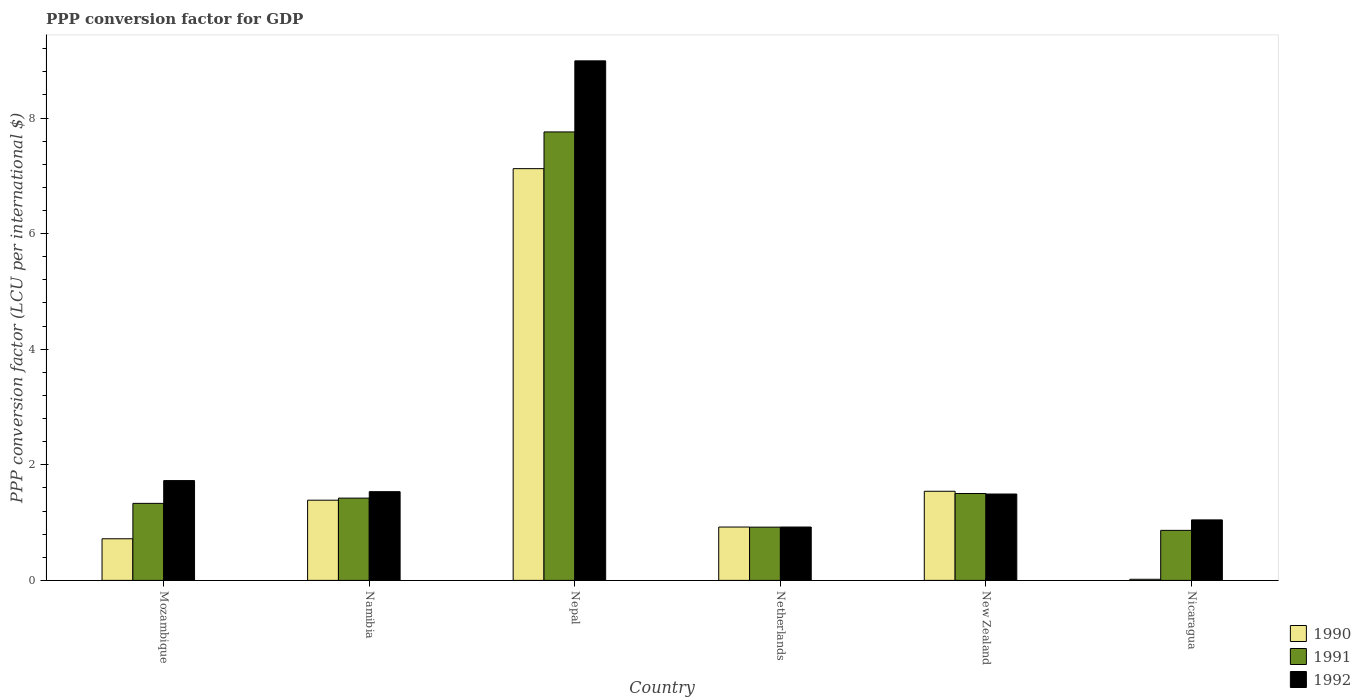How many different coloured bars are there?
Your response must be concise. 3. How many groups of bars are there?
Make the answer very short. 6. How many bars are there on the 5th tick from the left?
Provide a succinct answer. 3. How many bars are there on the 4th tick from the right?
Offer a terse response. 3. What is the label of the 6th group of bars from the left?
Ensure brevity in your answer.  Nicaragua. What is the PPP conversion factor for GDP in 1992 in Mozambique?
Ensure brevity in your answer.  1.73. Across all countries, what is the maximum PPP conversion factor for GDP in 1992?
Your response must be concise. 8.99. Across all countries, what is the minimum PPP conversion factor for GDP in 1990?
Your response must be concise. 0.02. In which country was the PPP conversion factor for GDP in 1991 maximum?
Keep it short and to the point. Nepal. In which country was the PPP conversion factor for GDP in 1992 minimum?
Keep it short and to the point. Netherlands. What is the total PPP conversion factor for GDP in 1992 in the graph?
Keep it short and to the point. 15.71. What is the difference between the PPP conversion factor for GDP in 1992 in Namibia and that in New Zealand?
Give a very brief answer. 0.04. What is the difference between the PPP conversion factor for GDP in 1992 in Nepal and the PPP conversion factor for GDP in 1991 in Namibia?
Your response must be concise. 7.57. What is the average PPP conversion factor for GDP in 1992 per country?
Your response must be concise. 2.62. What is the difference between the PPP conversion factor for GDP of/in 1990 and PPP conversion factor for GDP of/in 1992 in Nicaragua?
Your answer should be compact. -1.03. In how many countries, is the PPP conversion factor for GDP in 1990 greater than 7.2 LCU?
Your answer should be very brief. 0. What is the ratio of the PPP conversion factor for GDP in 1991 in Mozambique to that in New Zealand?
Give a very brief answer. 0.89. Is the difference between the PPP conversion factor for GDP in 1990 in Mozambique and Namibia greater than the difference between the PPP conversion factor for GDP in 1992 in Mozambique and Namibia?
Provide a short and direct response. No. What is the difference between the highest and the second highest PPP conversion factor for GDP in 1990?
Make the answer very short. 0.15. What is the difference between the highest and the lowest PPP conversion factor for GDP in 1990?
Your answer should be very brief. 7.1. What does the 1st bar from the right in Nicaragua represents?
Make the answer very short. 1992. How many bars are there?
Give a very brief answer. 18. Are all the bars in the graph horizontal?
Your response must be concise. No. How many countries are there in the graph?
Keep it short and to the point. 6. Does the graph contain any zero values?
Provide a short and direct response. No. How many legend labels are there?
Give a very brief answer. 3. What is the title of the graph?
Your response must be concise. PPP conversion factor for GDP. What is the label or title of the X-axis?
Make the answer very short. Country. What is the label or title of the Y-axis?
Give a very brief answer. PPP conversion factor (LCU per international $). What is the PPP conversion factor (LCU per international $) in 1990 in Mozambique?
Your answer should be very brief. 0.72. What is the PPP conversion factor (LCU per international $) in 1991 in Mozambique?
Give a very brief answer. 1.33. What is the PPP conversion factor (LCU per international $) of 1992 in Mozambique?
Your response must be concise. 1.73. What is the PPP conversion factor (LCU per international $) of 1990 in Namibia?
Your answer should be compact. 1.39. What is the PPP conversion factor (LCU per international $) of 1991 in Namibia?
Give a very brief answer. 1.42. What is the PPP conversion factor (LCU per international $) in 1992 in Namibia?
Provide a succinct answer. 1.53. What is the PPP conversion factor (LCU per international $) of 1990 in Nepal?
Offer a terse response. 7.12. What is the PPP conversion factor (LCU per international $) in 1991 in Nepal?
Offer a terse response. 7.76. What is the PPP conversion factor (LCU per international $) of 1992 in Nepal?
Make the answer very short. 8.99. What is the PPP conversion factor (LCU per international $) of 1990 in Netherlands?
Offer a terse response. 0.92. What is the PPP conversion factor (LCU per international $) in 1991 in Netherlands?
Keep it short and to the point. 0.92. What is the PPP conversion factor (LCU per international $) in 1992 in Netherlands?
Your answer should be compact. 0.92. What is the PPP conversion factor (LCU per international $) of 1990 in New Zealand?
Offer a very short reply. 1.54. What is the PPP conversion factor (LCU per international $) in 1991 in New Zealand?
Make the answer very short. 1.5. What is the PPP conversion factor (LCU per international $) in 1992 in New Zealand?
Your answer should be compact. 1.49. What is the PPP conversion factor (LCU per international $) in 1990 in Nicaragua?
Your answer should be compact. 0.02. What is the PPP conversion factor (LCU per international $) of 1991 in Nicaragua?
Offer a very short reply. 0.87. What is the PPP conversion factor (LCU per international $) in 1992 in Nicaragua?
Provide a short and direct response. 1.05. Across all countries, what is the maximum PPP conversion factor (LCU per international $) in 1990?
Your answer should be very brief. 7.12. Across all countries, what is the maximum PPP conversion factor (LCU per international $) of 1991?
Provide a succinct answer. 7.76. Across all countries, what is the maximum PPP conversion factor (LCU per international $) of 1992?
Ensure brevity in your answer.  8.99. Across all countries, what is the minimum PPP conversion factor (LCU per international $) of 1990?
Offer a terse response. 0.02. Across all countries, what is the minimum PPP conversion factor (LCU per international $) of 1991?
Ensure brevity in your answer.  0.87. Across all countries, what is the minimum PPP conversion factor (LCU per international $) of 1992?
Keep it short and to the point. 0.92. What is the total PPP conversion factor (LCU per international $) in 1990 in the graph?
Provide a succinct answer. 11.72. What is the total PPP conversion factor (LCU per international $) in 1991 in the graph?
Your answer should be compact. 13.81. What is the total PPP conversion factor (LCU per international $) of 1992 in the graph?
Make the answer very short. 15.71. What is the difference between the PPP conversion factor (LCU per international $) in 1990 in Mozambique and that in Namibia?
Make the answer very short. -0.67. What is the difference between the PPP conversion factor (LCU per international $) in 1991 in Mozambique and that in Namibia?
Offer a terse response. -0.09. What is the difference between the PPP conversion factor (LCU per international $) of 1992 in Mozambique and that in Namibia?
Your answer should be compact. 0.19. What is the difference between the PPP conversion factor (LCU per international $) in 1990 in Mozambique and that in Nepal?
Offer a very short reply. -6.4. What is the difference between the PPP conversion factor (LCU per international $) of 1991 in Mozambique and that in Nepal?
Your response must be concise. -6.43. What is the difference between the PPP conversion factor (LCU per international $) in 1992 in Mozambique and that in Nepal?
Provide a short and direct response. -7.26. What is the difference between the PPP conversion factor (LCU per international $) in 1990 in Mozambique and that in Netherlands?
Provide a short and direct response. -0.2. What is the difference between the PPP conversion factor (LCU per international $) in 1991 in Mozambique and that in Netherlands?
Ensure brevity in your answer.  0.41. What is the difference between the PPP conversion factor (LCU per international $) of 1992 in Mozambique and that in Netherlands?
Your response must be concise. 0.8. What is the difference between the PPP conversion factor (LCU per international $) of 1990 in Mozambique and that in New Zealand?
Your answer should be very brief. -0.82. What is the difference between the PPP conversion factor (LCU per international $) in 1991 in Mozambique and that in New Zealand?
Keep it short and to the point. -0.17. What is the difference between the PPP conversion factor (LCU per international $) in 1992 in Mozambique and that in New Zealand?
Make the answer very short. 0.23. What is the difference between the PPP conversion factor (LCU per international $) in 1990 in Mozambique and that in Nicaragua?
Ensure brevity in your answer.  0.7. What is the difference between the PPP conversion factor (LCU per international $) in 1991 in Mozambique and that in Nicaragua?
Your answer should be compact. 0.47. What is the difference between the PPP conversion factor (LCU per international $) of 1992 in Mozambique and that in Nicaragua?
Give a very brief answer. 0.68. What is the difference between the PPP conversion factor (LCU per international $) in 1990 in Namibia and that in Nepal?
Provide a succinct answer. -5.74. What is the difference between the PPP conversion factor (LCU per international $) of 1991 in Namibia and that in Nepal?
Your response must be concise. -6.34. What is the difference between the PPP conversion factor (LCU per international $) in 1992 in Namibia and that in Nepal?
Keep it short and to the point. -7.45. What is the difference between the PPP conversion factor (LCU per international $) in 1990 in Namibia and that in Netherlands?
Ensure brevity in your answer.  0.46. What is the difference between the PPP conversion factor (LCU per international $) of 1991 in Namibia and that in Netherlands?
Ensure brevity in your answer.  0.5. What is the difference between the PPP conversion factor (LCU per international $) of 1992 in Namibia and that in Netherlands?
Your answer should be compact. 0.61. What is the difference between the PPP conversion factor (LCU per international $) of 1990 in Namibia and that in New Zealand?
Make the answer very short. -0.15. What is the difference between the PPP conversion factor (LCU per international $) in 1991 in Namibia and that in New Zealand?
Offer a very short reply. -0.08. What is the difference between the PPP conversion factor (LCU per international $) of 1992 in Namibia and that in New Zealand?
Offer a very short reply. 0.04. What is the difference between the PPP conversion factor (LCU per international $) of 1990 in Namibia and that in Nicaragua?
Provide a short and direct response. 1.37. What is the difference between the PPP conversion factor (LCU per international $) of 1991 in Namibia and that in Nicaragua?
Provide a short and direct response. 0.56. What is the difference between the PPP conversion factor (LCU per international $) in 1992 in Namibia and that in Nicaragua?
Make the answer very short. 0.49. What is the difference between the PPP conversion factor (LCU per international $) in 1990 in Nepal and that in Netherlands?
Offer a very short reply. 6.2. What is the difference between the PPP conversion factor (LCU per international $) in 1991 in Nepal and that in Netherlands?
Your response must be concise. 6.84. What is the difference between the PPP conversion factor (LCU per international $) in 1992 in Nepal and that in Netherlands?
Make the answer very short. 8.07. What is the difference between the PPP conversion factor (LCU per international $) of 1990 in Nepal and that in New Zealand?
Your answer should be very brief. 5.58. What is the difference between the PPP conversion factor (LCU per international $) in 1991 in Nepal and that in New Zealand?
Provide a succinct answer. 6.26. What is the difference between the PPP conversion factor (LCU per international $) of 1992 in Nepal and that in New Zealand?
Give a very brief answer. 7.49. What is the difference between the PPP conversion factor (LCU per international $) in 1990 in Nepal and that in Nicaragua?
Your answer should be compact. 7.1. What is the difference between the PPP conversion factor (LCU per international $) in 1991 in Nepal and that in Nicaragua?
Give a very brief answer. 6.89. What is the difference between the PPP conversion factor (LCU per international $) of 1992 in Nepal and that in Nicaragua?
Make the answer very short. 7.94. What is the difference between the PPP conversion factor (LCU per international $) in 1990 in Netherlands and that in New Zealand?
Your answer should be very brief. -0.62. What is the difference between the PPP conversion factor (LCU per international $) of 1991 in Netherlands and that in New Zealand?
Offer a very short reply. -0.58. What is the difference between the PPP conversion factor (LCU per international $) in 1992 in Netherlands and that in New Zealand?
Your response must be concise. -0.57. What is the difference between the PPP conversion factor (LCU per international $) of 1990 in Netherlands and that in Nicaragua?
Offer a very short reply. 0.9. What is the difference between the PPP conversion factor (LCU per international $) of 1991 in Netherlands and that in Nicaragua?
Make the answer very short. 0.06. What is the difference between the PPP conversion factor (LCU per international $) of 1992 in Netherlands and that in Nicaragua?
Keep it short and to the point. -0.12. What is the difference between the PPP conversion factor (LCU per international $) of 1990 in New Zealand and that in Nicaragua?
Your response must be concise. 1.52. What is the difference between the PPP conversion factor (LCU per international $) of 1991 in New Zealand and that in Nicaragua?
Provide a succinct answer. 0.64. What is the difference between the PPP conversion factor (LCU per international $) of 1992 in New Zealand and that in Nicaragua?
Your answer should be very brief. 0.45. What is the difference between the PPP conversion factor (LCU per international $) in 1990 in Mozambique and the PPP conversion factor (LCU per international $) in 1991 in Namibia?
Provide a succinct answer. -0.7. What is the difference between the PPP conversion factor (LCU per international $) of 1990 in Mozambique and the PPP conversion factor (LCU per international $) of 1992 in Namibia?
Give a very brief answer. -0.81. What is the difference between the PPP conversion factor (LCU per international $) in 1991 in Mozambique and the PPP conversion factor (LCU per international $) in 1992 in Namibia?
Offer a very short reply. -0.2. What is the difference between the PPP conversion factor (LCU per international $) in 1990 in Mozambique and the PPP conversion factor (LCU per international $) in 1991 in Nepal?
Offer a very short reply. -7.04. What is the difference between the PPP conversion factor (LCU per international $) of 1990 in Mozambique and the PPP conversion factor (LCU per international $) of 1992 in Nepal?
Keep it short and to the point. -8.27. What is the difference between the PPP conversion factor (LCU per international $) in 1991 in Mozambique and the PPP conversion factor (LCU per international $) in 1992 in Nepal?
Ensure brevity in your answer.  -7.66. What is the difference between the PPP conversion factor (LCU per international $) of 1990 in Mozambique and the PPP conversion factor (LCU per international $) of 1991 in Netherlands?
Ensure brevity in your answer.  -0.2. What is the difference between the PPP conversion factor (LCU per international $) in 1990 in Mozambique and the PPP conversion factor (LCU per international $) in 1992 in Netherlands?
Provide a short and direct response. -0.2. What is the difference between the PPP conversion factor (LCU per international $) of 1991 in Mozambique and the PPP conversion factor (LCU per international $) of 1992 in Netherlands?
Make the answer very short. 0.41. What is the difference between the PPP conversion factor (LCU per international $) of 1990 in Mozambique and the PPP conversion factor (LCU per international $) of 1991 in New Zealand?
Your answer should be very brief. -0.78. What is the difference between the PPP conversion factor (LCU per international $) in 1990 in Mozambique and the PPP conversion factor (LCU per international $) in 1992 in New Zealand?
Provide a succinct answer. -0.77. What is the difference between the PPP conversion factor (LCU per international $) in 1991 in Mozambique and the PPP conversion factor (LCU per international $) in 1992 in New Zealand?
Your answer should be very brief. -0.16. What is the difference between the PPP conversion factor (LCU per international $) of 1990 in Mozambique and the PPP conversion factor (LCU per international $) of 1991 in Nicaragua?
Keep it short and to the point. -0.15. What is the difference between the PPP conversion factor (LCU per international $) in 1990 in Mozambique and the PPP conversion factor (LCU per international $) in 1992 in Nicaragua?
Keep it short and to the point. -0.33. What is the difference between the PPP conversion factor (LCU per international $) in 1991 in Mozambique and the PPP conversion factor (LCU per international $) in 1992 in Nicaragua?
Offer a terse response. 0.29. What is the difference between the PPP conversion factor (LCU per international $) of 1990 in Namibia and the PPP conversion factor (LCU per international $) of 1991 in Nepal?
Your answer should be very brief. -6.37. What is the difference between the PPP conversion factor (LCU per international $) of 1990 in Namibia and the PPP conversion factor (LCU per international $) of 1992 in Nepal?
Give a very brief answer. -7.6. What is the difference between the PPP conversion factor (LCU per international $) in 1991 in Namibia and the PPP conversion factor (LCU per international $) in 1992 in Nepal?
Provide a short and direct response. -7.57. What is the difference between the PPP conversion factor (LCU per international $) of 1990 in Namibia and the PPP conversion factor (LCU per international $) of 1991 in Netherlands?
Provide a succinct answer. 0.47. What is the difference between the PPP conversion factor (LCU per international $) in 1990 in Namibia and the PPP conversion factor (LCU per international $) in 1992 in Netherlands?
Your answer should be compact. 0.46. What is the difference between the PPP conversion factor (LCU per international $) of 1991 in Namibia and the PPP conversion factor (LCU per international $) of 1992 in Netherlands?
Provide a succinct answer. 0.5. What is the difference between the PPP conversion factor (LCU per international $) of 1990 in Namibia and the PPP conversion factor (LCU per international $) of 1991 in New Zealand?
Keep it short and to the point. -0.12. What is the difference between the PPP conversion factor (LCU per international $) of 1990 in Namibia and the PPP conversion factor (LCU per international $) of 1992 in New Zealand?
Your answer should be compact. -0.11. What is the difference between the PPP conversion factor (LCU per international $) of 1991 in Namibia and the PPP conversion factor (LCU per international $) of 1992 in New Zealand?
Provide a succinct answer. -0.07. What is the difference between the PPP conversion factor (LCU per international $) of 1990 in Namibia and the PPP conversion factor (LCU per international $) of 1991 in Nicaragua?
Provide a short and direct response. 0.52. What is the difference between the PPP conversion factor (LCU per international $) in 1990 in Namibia and the PPP conversion factor (LCU per international $) in 1992 in Nicaragua?
Provide a short and direct response. 0.34. What is the difference between the PPP conversion factor (LCU per international $) of 1991 in Namibia and the PPP conversion factor (LCU per international $) of 1992 in Nicaragua?
Offer a very short reply. 0.38. What is the difference between the PPP conversion factor (LCU per international $) in 1990 in Nepal and the PPP conversion factor (LCU per international $) in 1991 in Netherlands?
Keep it short and to the point. 6.2. What is the difference between the PPP conversion factor (LCU per international $) in 1990 in Nepal and the PPP conversion factor (LCU per international $) in 1992 in Netherlands?
Provide a short and direct response. 6.2. What is the difference between the PPP conversion factor (LCU per international $) of 1991 in Nepal and the PPP conversion factor (LCU per international $) of 1992 in Netherlands?
Provide a short and direct response. 6.84. What is the difference between the PPP conversion factor (LCU per international $) in 1990 in Nepal and the PPP conversion factor (LCU per international $) in 1991 in New Zealand?
Provide a succinct answer. 5.62. What is the difference between the PPP conversion factor (LCU per international $) in 1990 in Nepal and the PPP conversion factor (LCU per international $) in 1992 in New Zealand?
Keep it short and to the point. 5.63. What is the difference between the PPP conversion factor (LCU per international $) of 1991 in Nepal and the PPP conversion factor (LCU per international $) of 1992 in New Zealand?
Give a very brief answer. 6.26. What is the difference between the PPP conversion factor (LCU per international $) of 1990 in Nepal and the PPP conversion factor (LCU per international $) of 1991 in Nicaragua?
Make the answer very short. 6.26. What is the difference between the PPP conversion factor (LCU per international $) of 1990 in Nepal and the PPP conversion factor (LCU per international $) of 1992 in Nicaragua?
Provide a succinct answer. 6.08. What is the difference between the PPP conversion factor (LCU per international $) in 1991 in Nepal and the PPP conversion factor (LCU per international $) in 1992 in Nicaragua?
Provide a short and direct response. 6.71. What is the difference between the PPP conversion factor (LCU per international $) of 1990 in Netherlands and the PPP conversion factor (LCU per international $) of 1991 in New Zealand?
Give a very brief answer. -0.58. What is the difference between the PPP conversion factor (LCU per international $) in 1990 in Netherlands and the PPP conversion factor (LCU per international $) in 1992 in New Zealand?
Keep it short and to the point. -0.57. What is the difference between the PPP conversion factor (LCU per international $) in 1991 in Netherlands and the PPP conversion factor (LCU per international $) in 1992 in New Zealand?
Ensure brevity in your answer.  -0.57. What is the difference between the PPP conversion factor (LCU per international $) in 1990 in Netherlands and the PPP conversion factor (LCU per international $) in 1991 in Nicaragua?
Give a very brief answer. 0.06. What is the difference between the PPP conversion factor (LCU per international $) in 1990 in Netherlands and the PPP conversion factor (LCU per international $) in 1992 in Nicaragua?
Your answer should be compact. -0.12. What is the difference between the PPP conversion factor (LCU per international $) of 1991 in Netherlands and the PPP conversion factor (LCU per international $) of 1992 in Nicaragua?
Ensure brevity in your answer.  -0.13. What is the difference between the PPP conversion factor (LCU per international $) of 1990 in New Zealand and the PPP conversion factor (LCU per international $) of 1991 in Nicaragua?
Your response must be concise. 0.68. What is the difference between the PPP conversion factor (LCU per international $) of 1990 in New Zealand and the PPP conversion factor (LCU per international $) of 1992 in Nicaragua?
Make the answer very short. 0.5. What is the difference between the PPP conversion factor (LCU per international $) in 1991 in New Zealand and the PPP conversion factor (LCU per international $) in 1992 in Nicaragua?
Your answer should be very brief. 0.46. What is the average PPP conversion factor (LCU per international $) in 1990 per country?
Your answer should be compact. 1.95. What is the average PPP conversion factor (LCU per international $) of 1991 per country?
Provide a short and direct response. 2.3. What is the average PPP conversion factor (LCU per international $) of 1992 per country?
Make the answer very short. 2.62. What is the difference between the PPP conversion factor (LCU per international $) of 1990 and PPP conversion factor (LCU per international $) of 1991 in Mozambique?
Give a very brief answer. -0.61. What is the difference between the PPP conversion factor (LCU per international $) in 1990 and PPP conversion factor (LCU per international $) in 1992 in Mozambique?
Your answer should be very brief. -1.01. What is the difference between the PPP conversion factor (LCU per international $) in 1991 and PPP conversion factor (LCU per international $) in 1992 in Mozambique?
Make the answer very short. -0.39. What is the difference between the PPP conversion factor (LCU per international $) in 1990 and PPP conversion factor (LCU per international $) in 1991 in Namibia?
Your answer should be very brief. -0.04. What is the difference between the PPP conversion factor (LCU per international $) in 1990 and PPP conversion factor (LCU per international $) in 1992 in Namibia?
Keep it short and to the point. -0.15. What is the difference between the PPP conversion factor (LCU per international $) of 1991 and PPP conversion factor (LCU per international $) of 1992 in Namibia?
Ensure brevity in your answer.  -0.11. What is the difference between the PPP conversion factor (LCU per international $) in 1990 and PPP conversion factor (LCU per international $) in 1991 in Nepal?
Offer a very short reply. -0.64. What is the difference between the PPP conversion factor (LCU per international $) of 1990 and PPP conversion factor (LCU per international $) of 1992 in Nepal?
Ensure brevity in your answer.  -1.87. What is the difference between the PPP conversion factor (LCU per international $) of 1991 and PPP conversion factor (LCU per international $) of 1992 in Nepal?
Your answer should be compact. -1.23. What is the difference between the PPP conversion factor (LCU per international $) in 1990 and PPP conversion factor (LCU per international $) in 1991 in Netherlands?
Your answer should be compact. 0. What is the difference between the PPP conversion factor (LCU per international $) of 1990 and PPP conversion factor (LCU per international $) of 1992 in Netherlands?
Offer a terse response. -0. What is the difference between the PPP conversion factor (LCU per international $) in 1991 and PPP conversion factor (LCU per international $) in 1992 in Netherlands?
Your answer should be compact. -0. What is the difference between the PPP conversion factor (LCU per international $) of 1990 and PPP conversion factor (LCU per international $) of 1991 in New Zealand?
Make the answer very short. 0.04. What is the difference between the PPP conversion factor (LCU per international $) of 1990 and PPP conversion factor (LCU per international $) of 1992 in New Zealand?
Provide a short and direct response. 0.05. What is the difference between the PPP conversion factor (LCU per international $) of 1991 and PPP conversion factor (LCU per international $) of 1992 in New Zealand?
Give a very brief answer. 0.01. What is the difference between the PPP conversion factor (LCU per international $) in 1990 and PPP conversion factor (LCU per international $) in 1991 in Nicaragua?
Offer a terse response. -0.85. What is the difference between the PPP conversion factor (LCU per international $) of 1990 and PPP conversion factor (LCU per international $) of 1992 in Nicaragua?
Make the answer very short. -1.03. What is the difference between the PPP conversion factor (LCU per international $) in 1991 and PPP conversion factor (LCU per international $) in 1992 in Nicaragua?
Your answer should be very brief. -0.18. What is the ratio of the PPP conversion factor (LCU per international $) of 1990 in Mozambique to that in Namibia?
Offer a very short reply. 0.52. What is the ratio of the PPP conversion factor (LCU per international $) of 1991 in Mozambique to that in Namibia?
Give a very brief answer. 0.94. What is the ratio of the PPP conversion factor (LCU per international $) in 1992 in Mozambique to that in Namibia?
Offer a very short reply. 1.13. What is the ratio of the PPP conversion factor (LCU per international $) in 1990 in Mozambique to that in Nepal?
Provide a short and direct response. 0.1. What is the ratio of the PPP conversion factor (LCU per international $) in 1991 in Mozambique to that in Nepal?
Offer a terse response. 0.17. What is the ratio of the PPP conversion factor (LCU per international $) in 1992 in Mozambique to that in Nepal?
Make the answer very short. 0.19. What is the ratio of the PPP conversion factor (LCU per international $) in 1990 in Mozambique to that in Netherlands?
Offer a terse response. 0.78. What is the ratio of the PPP conversion factor (LCU per international $) in 1991 in Mozambique to that in Netherlands?
Your answer should be very brief. 1.45. What is the ratio of the PPP conversion factor (LCU per international $) of 1992 in Mozambique to that in Netherlands?
Your answer should be compact. 1.87. What is the ratio of the PPP conversion factor (LCU per international $) of 1990 in Mozambique to that in New Zealand?
Make the answer very short. 0.47. What is the ratio of the PPP conversion factor (LCU per international $) in 1991 in Mozambique to that in New Zealand?
Keep it short and to the point. 0.89. What is the ratio of the PPP conversion factor (LCU per international $) in 1992 in Mozambique to that in New Zealand?
Your answer should be very brief. 1.16. What is the ratio of the PPP conversion factor (LCU per international $) in 1990 in Mozambique to that in Nicaragua?
Offer a terse response. 37.23. What is the ratio of the PPP conversion factor (LCU per international $) in 1991 in Mozambique to that in Nicaragua?
Offer a very short reply. 1.54. What is the ratio of the PPP conversion factor (LCU per international $) in 1992 in Mozambique to that in Nicaragua?
Ensure brevity in your answer.  1.65. What is the ratio of the PPP conversion factor (LCU per international $) in 1990 in Namibia to that in Nepal?
Make the answer very short. 0.19. What is the ratio of the PPP conversion factor (LCU per international $) of 1991 in Namibia to that in Nepal?
Give a very brief answer. 0.18. What is the ratio of the PPP conversion factor (LCU per international $) in 1992 in Namibia to that in Nepal?
Your response must be concise. 0.17. What is the ratio of the PPP conversion factor (LCU per international $) of 1990 in Namibia to that in Netherlands?
Ensure brevity in your answer.  1.5. What is the ratio of the PPP conversion factor (LCU per international $) in 1991 in Namibia to that in Netherlands?
Provide a succinct answer. 1.54. What is the ratio of the PPP conversion factor (LCU per international $) of 1992 in Namibia to that in Netherlands?
Your answer should be very brief. 1.66. What is the ratio of the PPP conversion factor (LCU per international $) in 1990 in Namibia to that in New Zealand?
Your answer should be very brief. 0.9. What is the ratio of the PPP conversion factor (LCU per international $) in 1991 in Namibia to that in New Zealand?
Ensure brevity in your answer.  0.95. What is the ratio of the PPP conversion factor (LCU per international $) of 1992 in Namibia to that in New Zealand?
Your response must be concise. 1.03. What is the ratio of the PPP conversion factor (LCU per international $) of 1990 in Namibia to that in Nicaragua?
Offer a terse response. 71.74. What is the ratio of the PPP conversion factor (LCU per international $) of 1991 in Namibia to that in Nicaragua?
Offer a terse response. 1.64. What is the ratio of the PPP conversion factor (LCU per international $) of 1992 in Namibia to that in Nicaragua?
Keep it short and to the point. 1.47. What is the ratio of the PPP conversion factor (LCU per international $) in 1990 in Nepal to that in Netherlands?
Your answer should be very brief. 7.72. What is the ratio of the PPP conversion factor (LCU per international $) of 1991 in Nepal to that in Netherlands?
Your answer should be compact. 8.42. What is the ratio of the PPP conversion factor (LCU per international $) in 1992 in Nepal to that in Netherlands?
Your response must be concise. 9.74. What is the ratio of the PPP conversion factor (LCU per international $) of 1990 in Nepal to that in New Zealand?
Keep it short and to the point. 4.62. What is the ratio of the PPP conversion factor (LCU per international $) in 1991 in Nepal to that in New Zealand?
Provide a succinct answer. 5.16. What is the ratio of the PPP conversion factor (LCU per international $) of 1992 in Nepal to that in New Zealand?
Give a very brief answer. 6.02. What is the ratio of the PPP conversion factor (LCU per international $) in 1990 in Nepal to that in Nicaragua?
Offer a very short reply. 368.31. What is the ratio of the PPP conversion factor (LCU per international $) of 1991 in Nepal to that in Nicaragua?
Provide a short and direct response. 8.96. What is the ratio of the PPP conversion factor (LCU per international $) of 1992 in Nepal to that in Nicaragua?
Offer a terse response. 8.59. What is the ratio of the PPP conversion factor (LCU per international $) in 1990 in Netherlands to that in New Zealand?
Offer a very short reply. 0.6. What is the ratio of the PPP conversion factor (LCU per international $) in 1991 in Netherlands to that in New Zealand?
Provide a succinct answer. 0.61. What is the ratio of the PPP conversion factor (LCU per international $) in 1992 in Netherlands to that in New Zealand?
Your response must be concise. 0.62. What is the ratio of the PPP conversion factor (LCU per international $) in 1990 in Netherlands to that in Nicaragua?
Offer a very short reply. 47.73. What is the ratio of the PPP conversion factor (LCU per international $) of 1991 in Netherlands to that in Nicaragua?
Ensure brevity in your answer.  1.06. What is the ratio of the PPP conversion factor (LCU per international $) of 1992 in Netherlands to that in Nicaragua?
Make the answer very short. 0.88. What is the ratio of the PPP conversion factor (LCU per international $) of 1990 in New Zealand to that in Nicaragua?
Your answer should be very brief. 79.72. What is the ratio of the PPP conversion factor (LCU per international $) in 1991 in New Zealand to that in Nicaragua?
Provide a short and direct response. 1.74. What is the ratio of the PPP conversion factor (LCU per international $) of 1992 in New Zealand to that in Nicaragua?
Make the answer very short. 1.43. What is the difference between the highest and the second highest PPP conversion factor (LCU per international $) of 1990?
Offer a terse response. 5.58. What is the difference between the highest and the second highest PPP conversion factor (LCU per international $) of 1991?
Your answer should be compact. 6.26. What is the difference between the highest and the second highest PPP conversion factor (LCU per international $) in 1992?
Ensure brevity in your answer.  7.26. What is the difference between the highest and the lowest PPP conversion factor (LCU per international $) in 1990?
Your response must be concise. 7.1. What is the difference between the highest and the lowest PPP conversion factor (LCU per international $) of 1991?
Make the answer very short. 6.89. What is the difference between the highest and the lowest PPP conversion factor (LCU per international $) in 1992?
Offer a terse response. 8.07. 